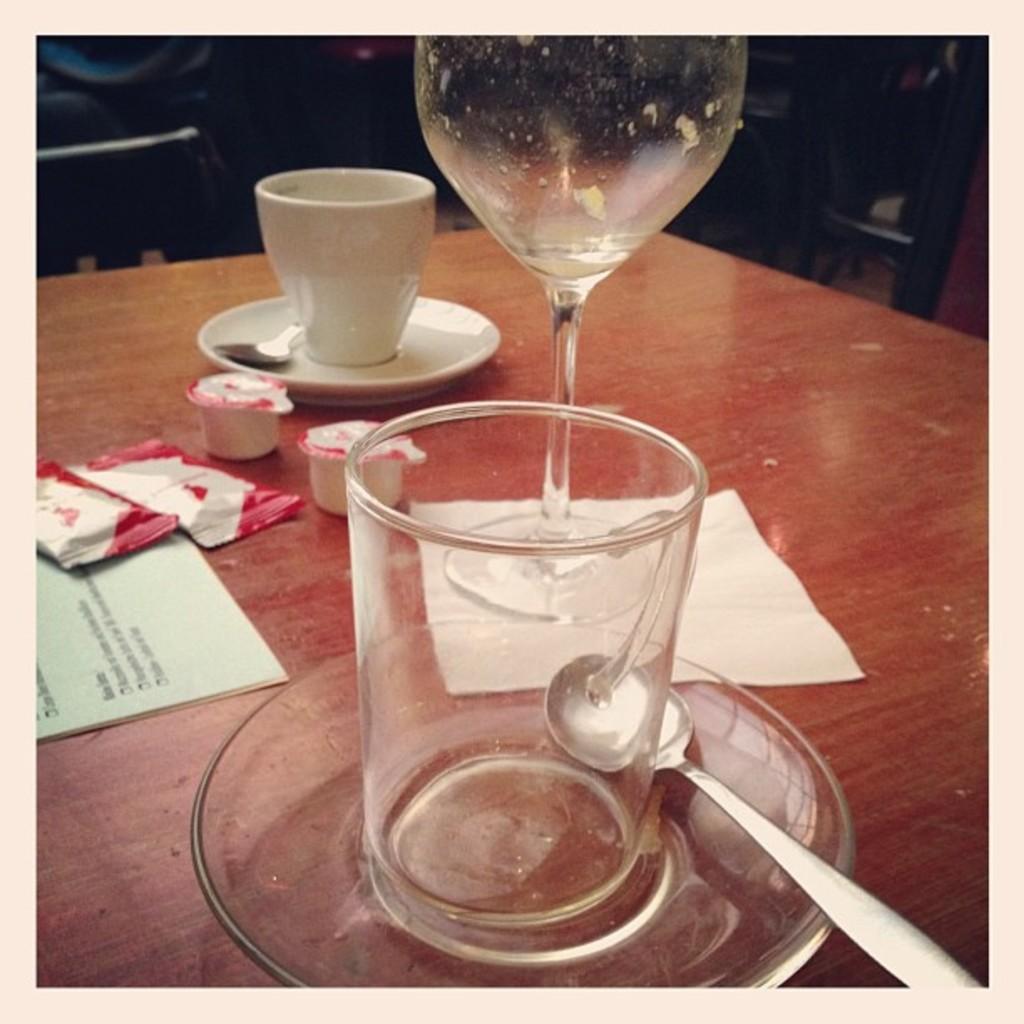Please provide a concise description of this image. In this image we can see a table. On the table there are cutlery, crockery, papers and some frozen food. 